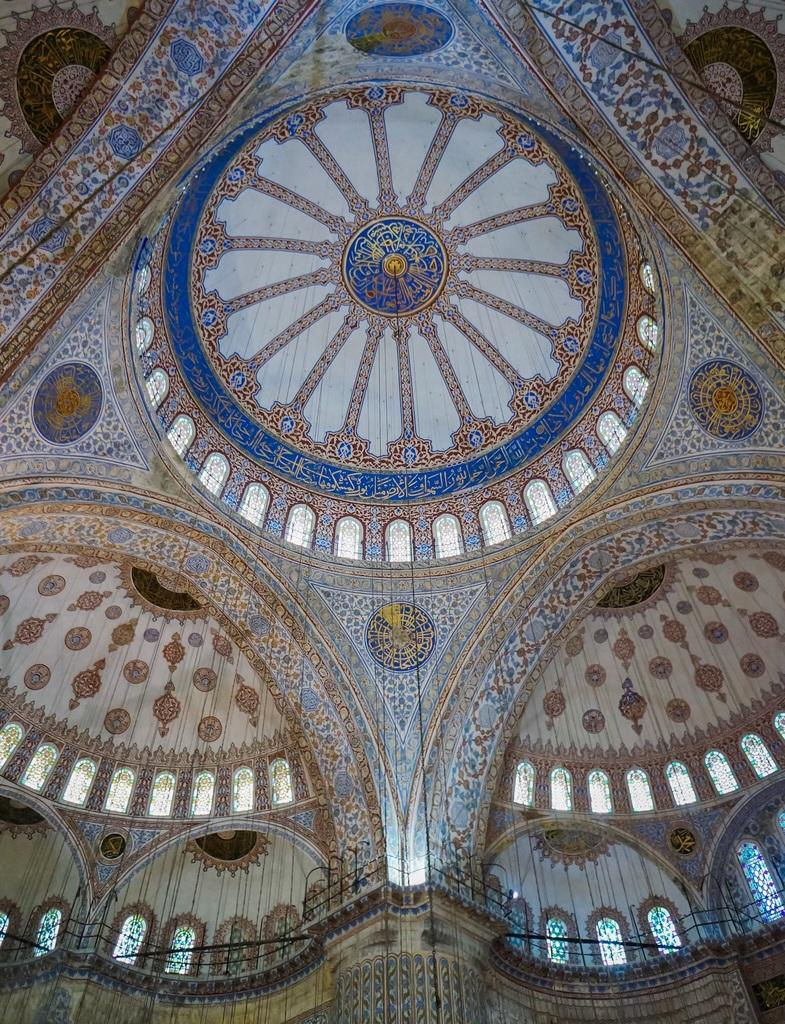What part of the building is shown in the image? The image is of a ceiling, and there is a fence at the bottom of the image, which suggests it was likely taken inside a building. What can be seen behind the fence in the image? Windows are visible behind the fence in the image. What is the main feature of the ceiling in the image? The ceiling has many designs on it. How many fence sections are visible in the image? It is not possible to determine the exact number of fence sections from the provided facts. What type of apple is being rolled across the ceiling in the image? There is no apple present in the image, and therefore no such activity can be observed. 